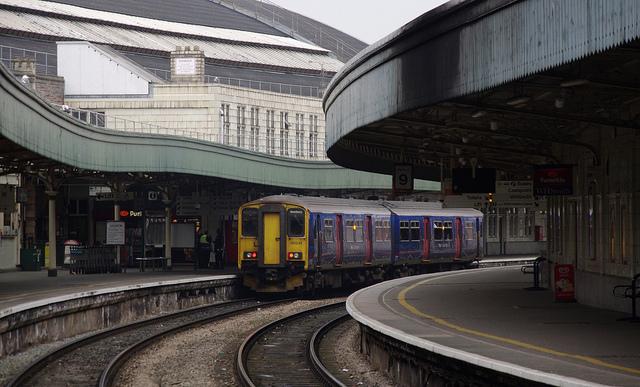Where is the train?
Be succinct. On tracks. How many trains are there?
Keep it brief. 1. Will the doors open on both sides?
Quick response, please. Yes. 